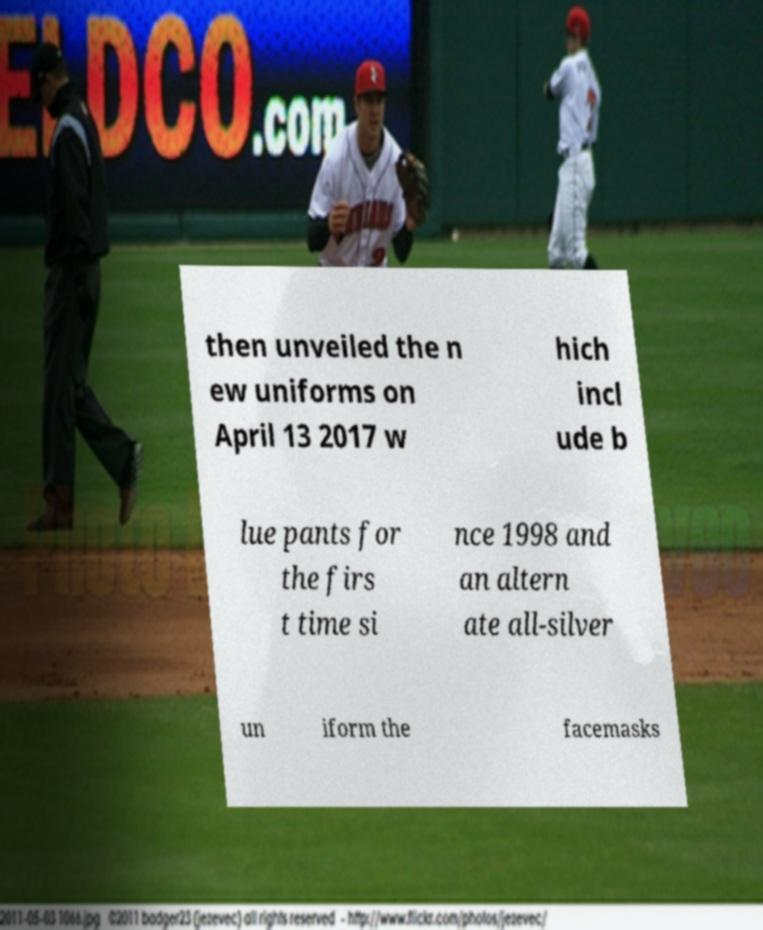Please identify and transcribe the text found in this image. then unveiled the n ew uniforms on April 13 2017 w hich incl ude b lue pants for the firs t time si nce 1998 and an altern ate all-silver un iform the facemasks 